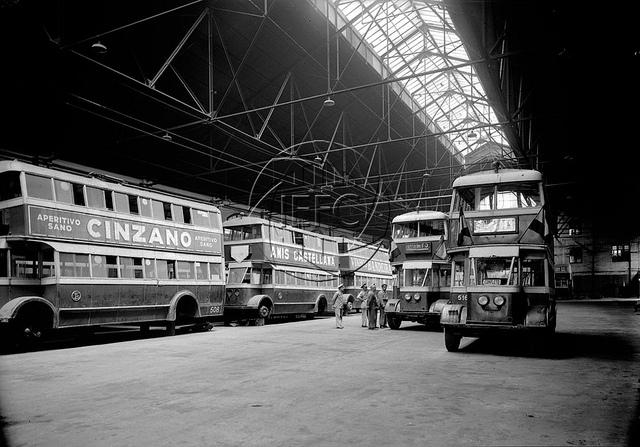How many trucks are in this garage?
Keep it brief. 5. What is the primary purpose of the white vehicle?
Keep it brief. Transportation. Which country are these buses from?
Quick response, please. Italy. Are these vintage buses?
Answer briefly. Yes. Is this truck operational?
Keep it brief. Yes. What color is the trolley?
Short answer required. Gray. Is the photo colored?
Quick response, please. No. 